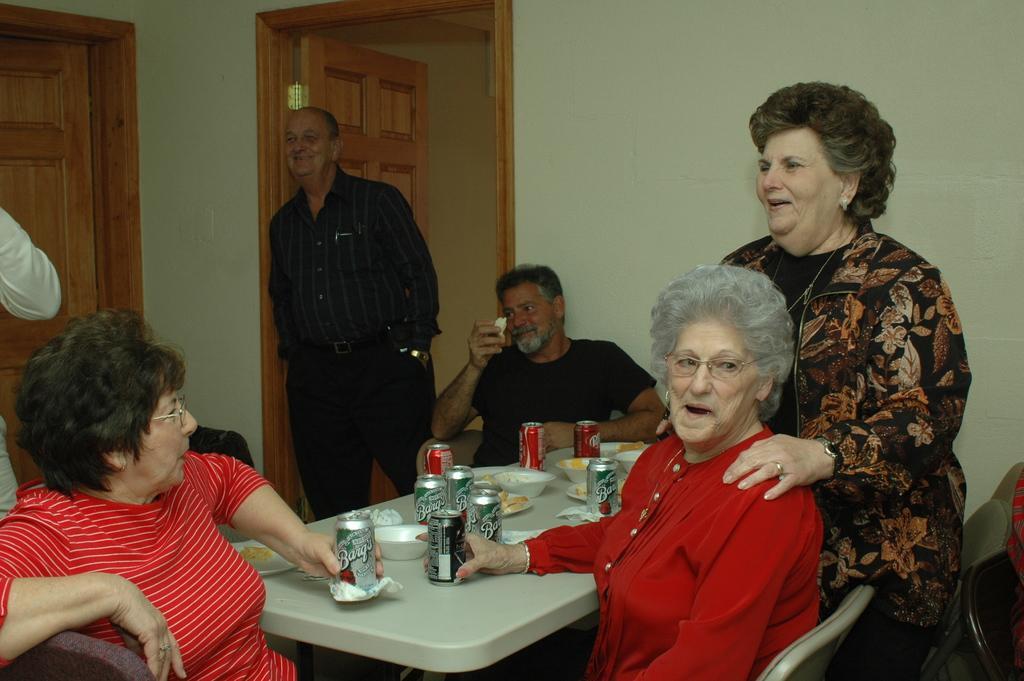How would you summarize this image in a sentence or two? In this image I can see the group of people with different color dresses. There is a table in-front of these people. On the table I can see the bowls with food and tins. In the background I can see the wall and the door. 